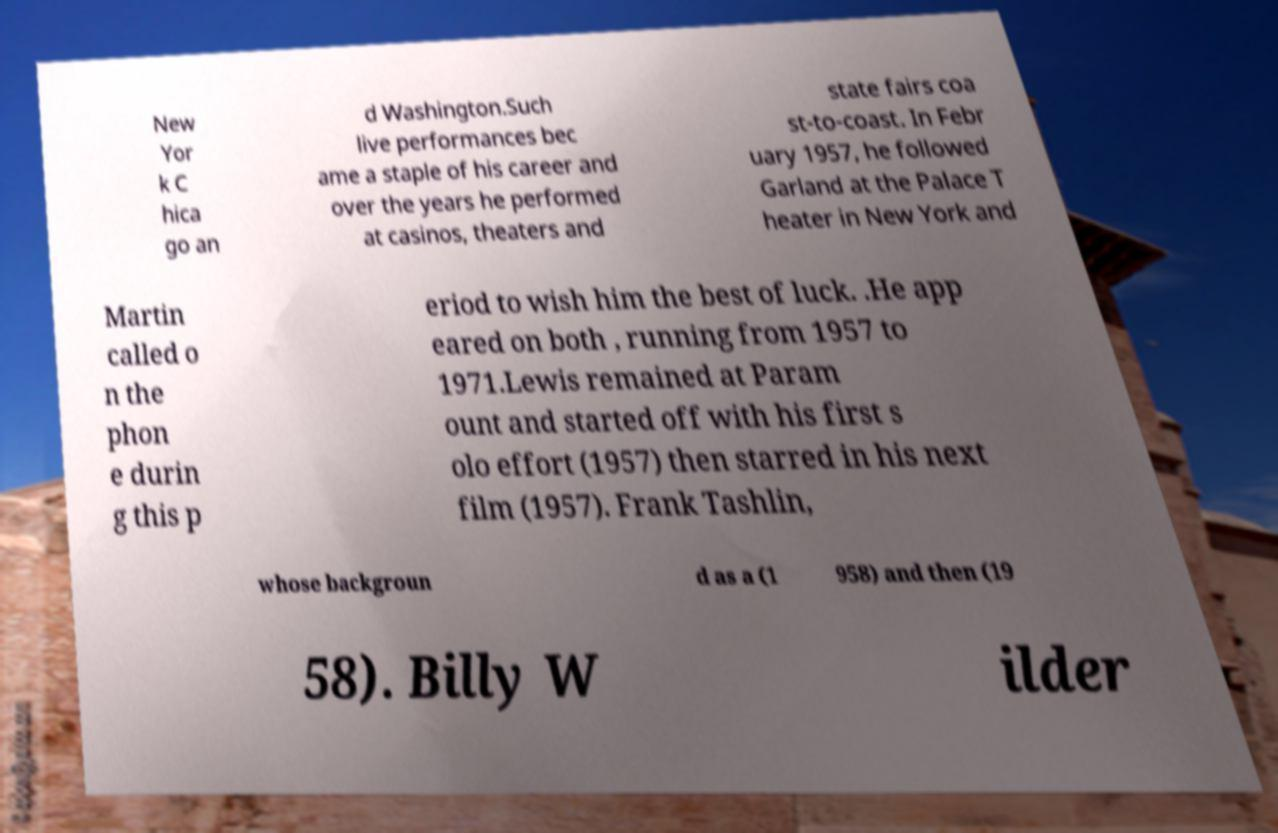For documentation purposes, I need the text within this image transcribed. Could you provide that? New Yor k C hica go an d Washington.Such live performances bec ame a staple of his career and over the years he performed at casinos, theaters and state fairs coa st-to-coast. In Febr uary 1957, he followed Garland at the Palace T heater in New York and Martin called o n the phon e durin g this p eriod to wish him the best of luck. .He app eared on both , running from 1957 to 1971.Lewis remained at Param ount and started off with his first s olo effort (1957) then starred in his next film (1957). Frank Tashlin, whose backgroun d as a (1 958) and then (19 58). Billy W ilder 